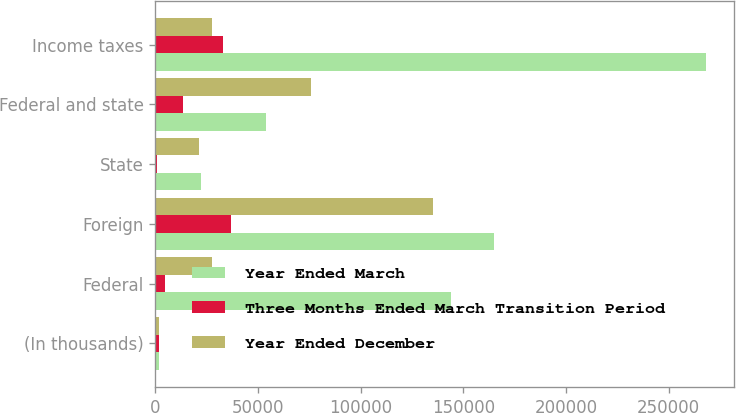<chart> <loc_0><loc_0><loc_500><loc_500><stacked_bar_chart><ecel><fcel>(In thousands)<fcel>Federal<fcel>Foreign<fcel>State<fcel>Federal and state<fcel>Income taxes<nl><fcel>Year Ended March<fcel>2019<fcel>143872<fcel>164974<fcel>22455<fcel>53715<fcel>268400<nl><fcel>Three Months Ended March Transition Period<fcel>2018<fcel>4864<fcel>36634<fcel>896<fcel>13656<fcel>32969<nl><fcel>Year Ended December<fcel>2017<fcel>27712<fcel>135007<fcel>21506<fcel>76039<fcel>27712<nl></chart> 